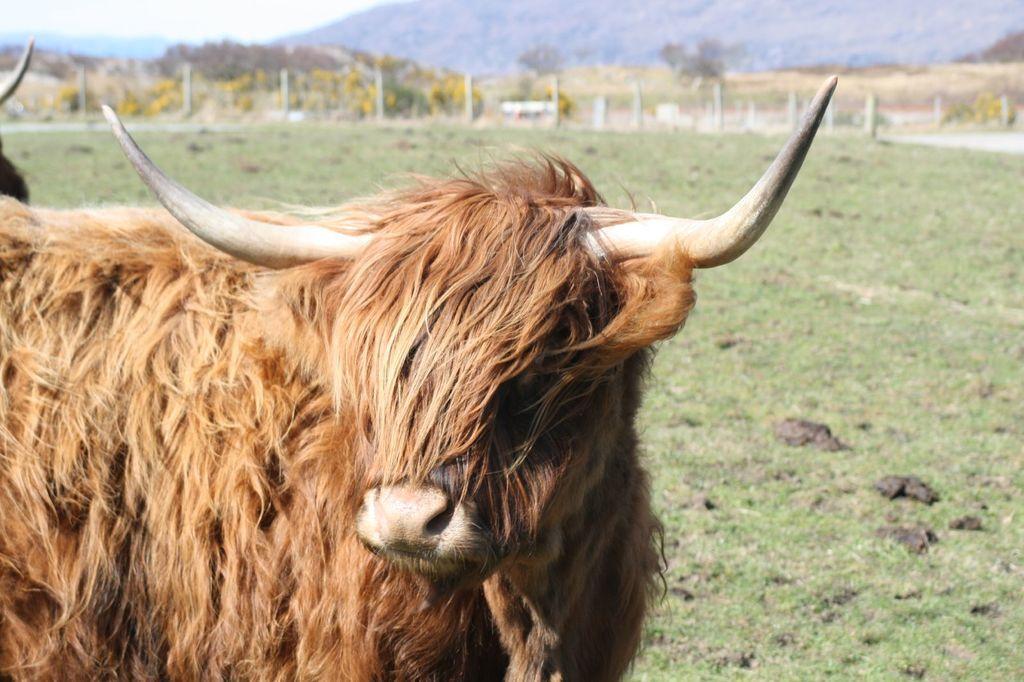How would you summarize this image in a sentence or two? In this image I can see an animal which is brown in color is standing on the ground. In the background I can see few poles, few trees, few flowers which are yellow in color, a mountain and the sky. 